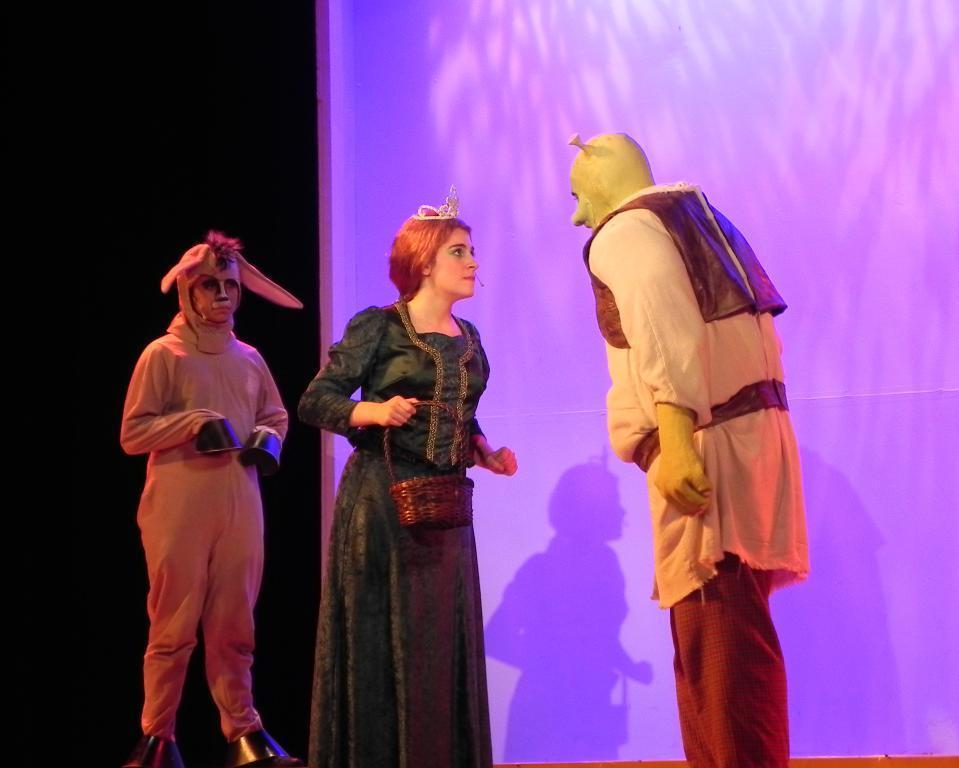Can you describe this image briefly? In this image I can see three people standing. These people are wearing the costumes which are in different color. I can see one person is wearing the crown. In the back there is a banner. And to the left there is a black background. 